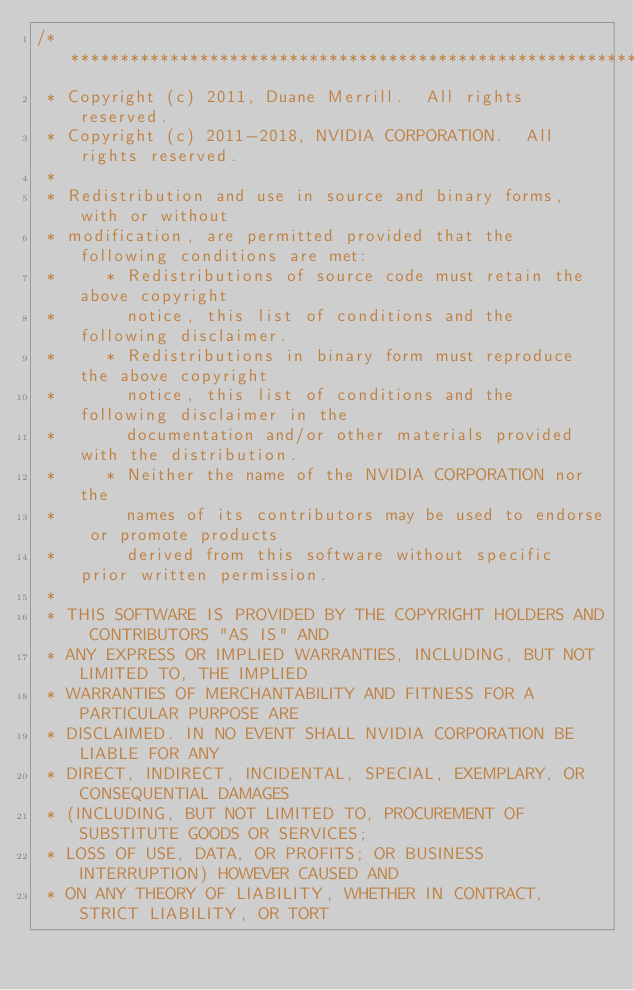<code> <loc_0><loc_0><loc_500><loc_500><_Cuda_>/******************************************************************************
 * Copyright (c) 2011, Duane Merrill.  All rights reserved.
 * Copyright (c) 2011-2018, NVIDIA CORPORATION.  All rights reserved.
 *
 * Redistribution and use in source and binary forms, with or without
 * modification, are permitted provided that the following conditions are met:
 *     * Redistributions of source code must retain the above copyright
 *       notice, this list of conditions and the following disclaimer.
 *     * Redistributions in binary form must reproduce the above copyright
 *       notice, this list of conditions and the following disclaimer in the
 *       documentation and/or other materials provided with the distribution.
 *     * Neither the name of the NVIDIA CORPORATION nor the
 *       names of its contributors may be used to endorse or promote products
 *       derived from this software without specific prior written permission.
 *
 * THIS SOFTWARE IS PROVIDED BY THE COPYRIGHT HOLDERS AND CONTRIBUTORS "AS IS" AND
 * ANY EXPRESS OR IMPLIED WARRANTIES, INCLUDING, BUT NOT LIMITED TO, THE IMPLIED
 * WARRANTIES OF MERCHANTABILITY AND FITNESS FOR A PARTICULAR PURPOSE ARE
 * DISCLAIMED. IN NO EVENT SHALL NVIDIA CORPORATION BE LIABLE FOR ANY
 * DIRECT, INDIRECT, INCIDENTAL, SPECIAL, EXEMPLARY, OR CONSEQUENTIAL DAMAGES
 * (INCLUDING, BUT NOT LIMITED TO, PROCUREMENT OF SUBSTITUTE GOODS OR SERVICES;
 * LOSS OF USE, DATA, OR PROFITS; OR BUSINESS INTERRUPTION) HOWEVER CAUSED AND
 * ON ANY THEORY OF LIABILITY, WHETHER IN CONTRACT, STRICT LIABILITY, OR TORT</code> 